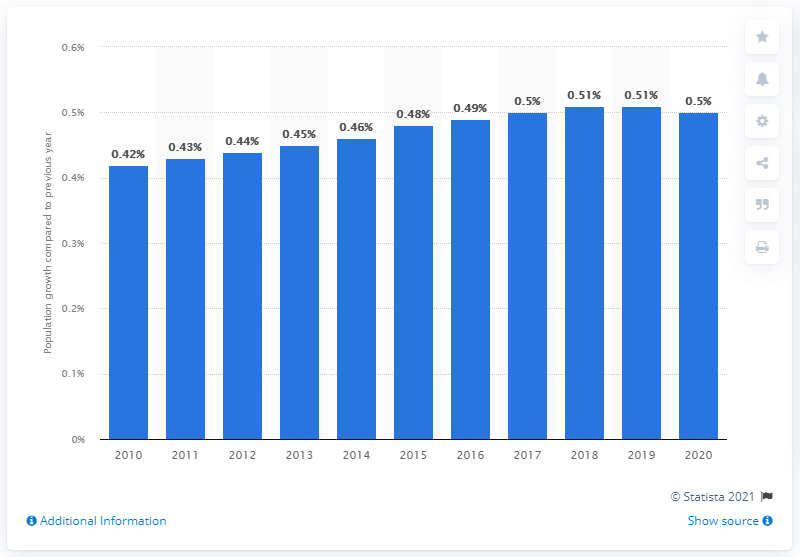Highlight a few significant elements in this photo. El Salvador's population increased by 0.5% in 2020. 